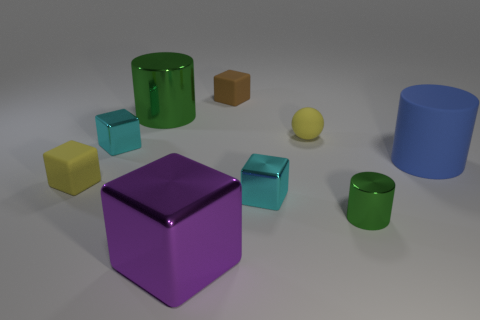Subtract 1 cubes. How many cubes are left? 4 Subtract all purple blocks. How many blocks are left? 4 Subtract all small yellow cubes. How many cubes are left? 4 Subtract all red blocks. Subtract all green cylinders. How many blocks are left? 5 Subtract all spheres. How many objects are left? 8 Add 7 green things. How many green things are left? 9 Add 4 big green shiny objects. How many big green shiny objects exist? 5 Subtract 1 yellow blocks. How many objects are left? 8 Subtract all purple cubes. Subtract all small green shiny cylinders. How many objects are left? 7 